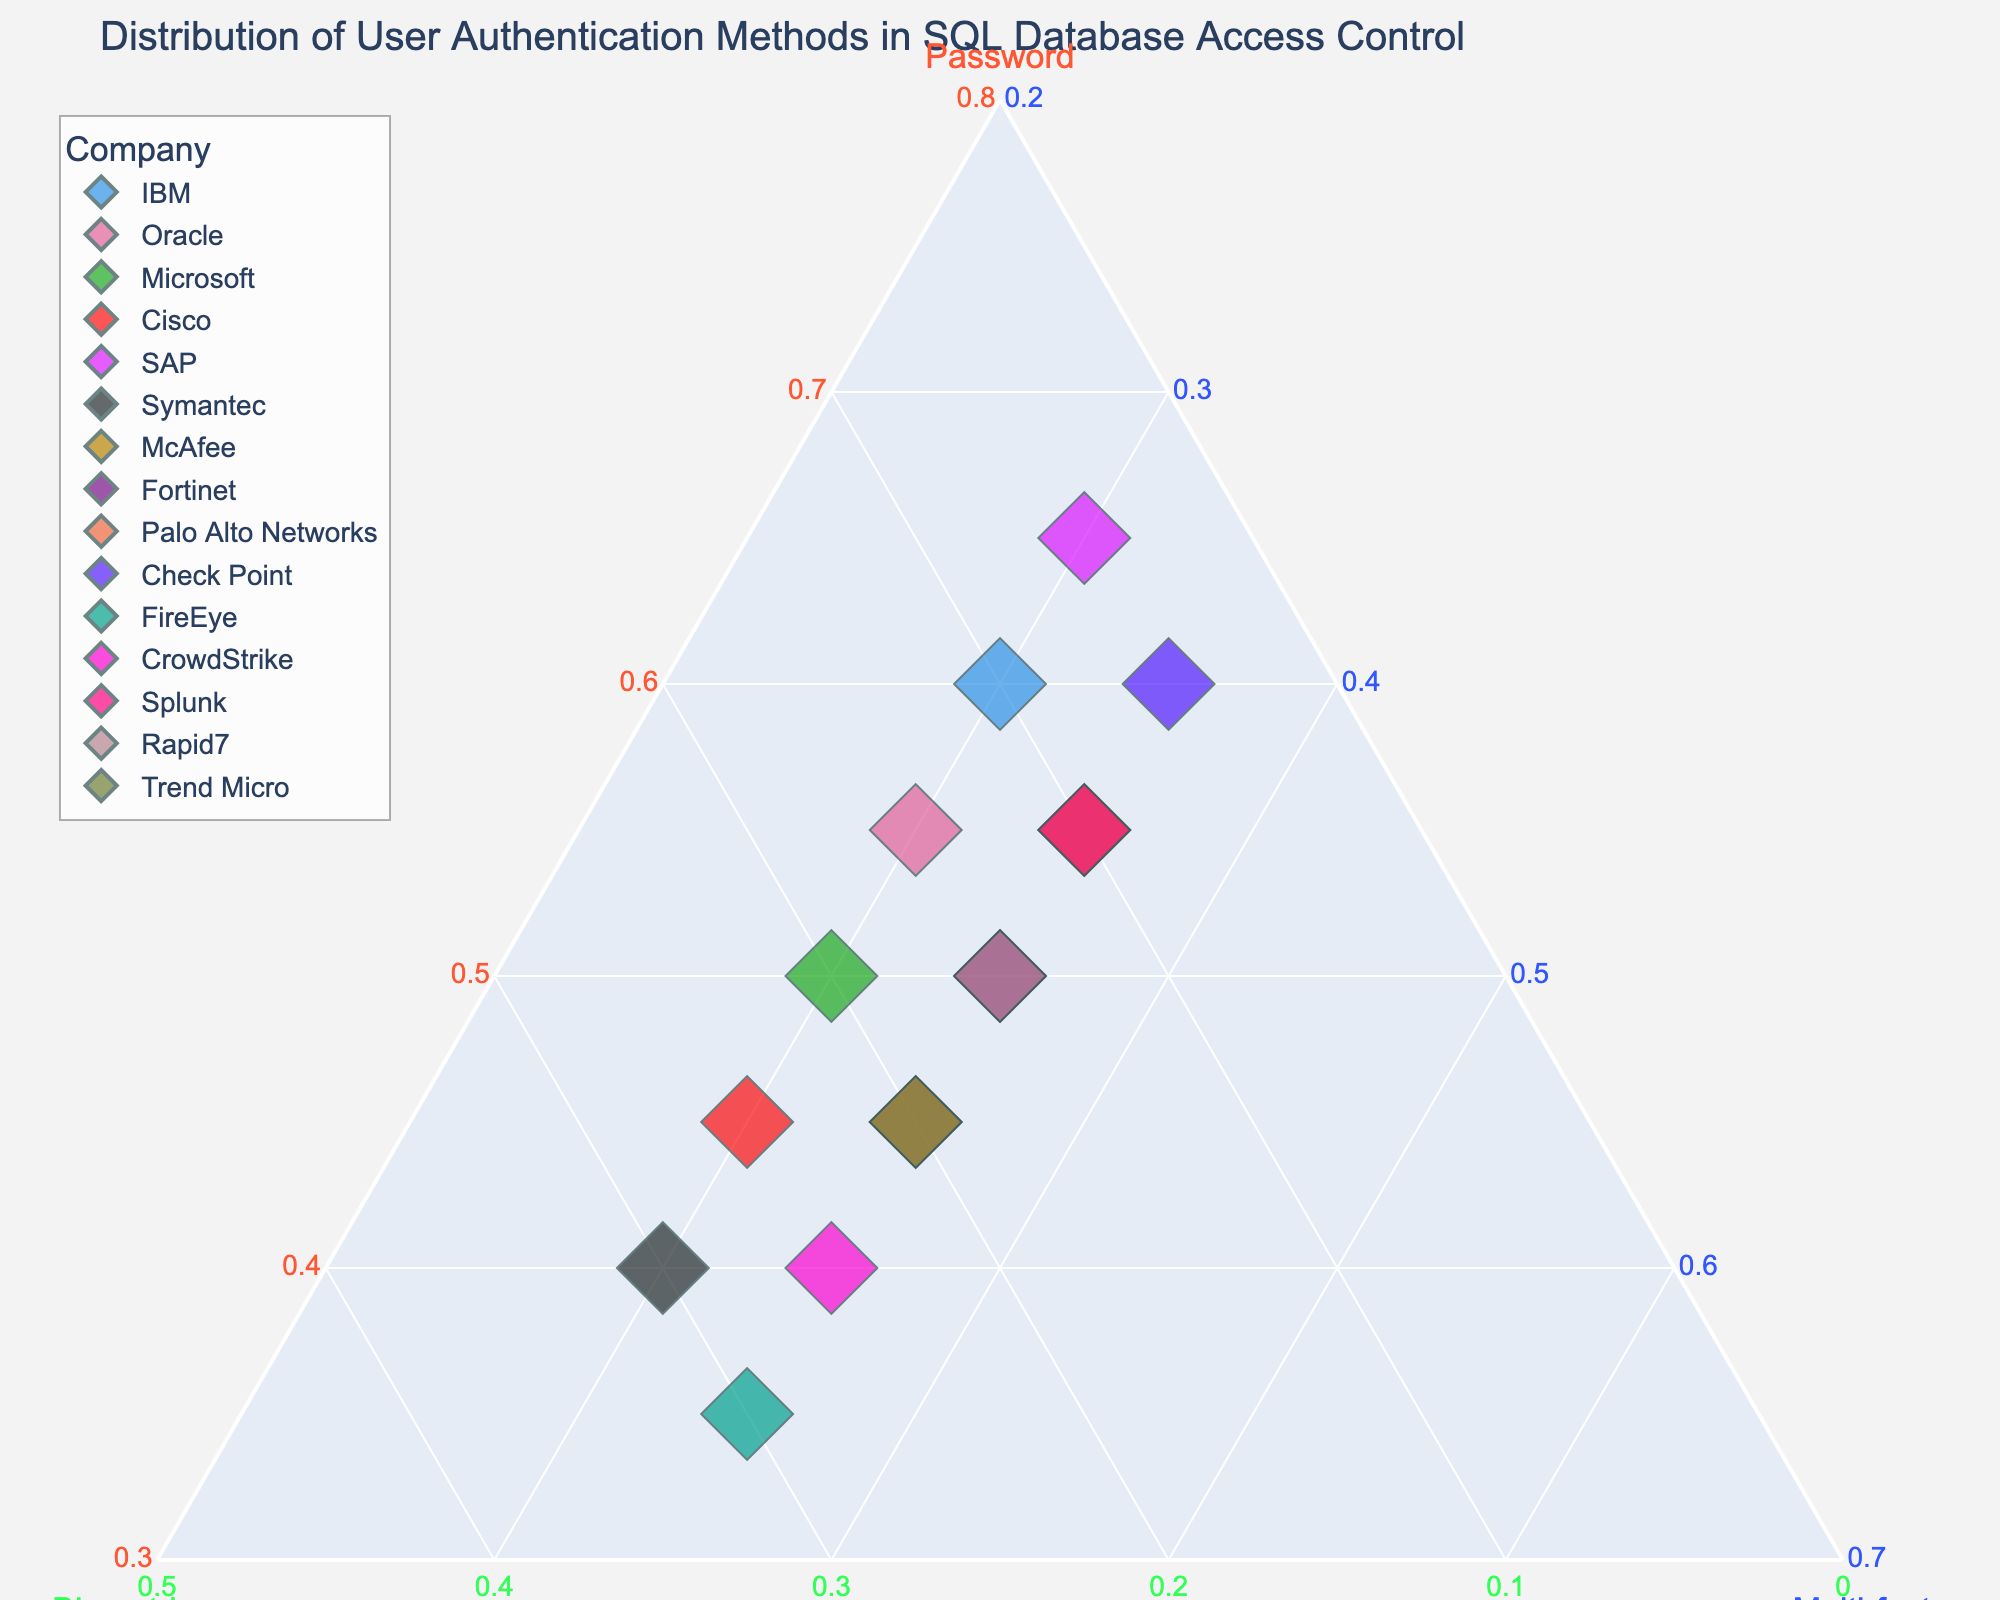What's the title of the figure? The title is prominently displayed at the top of the plot and provides a summary of what the plot represents.
Answer: Distribution of User Authentication Methods in SQL Database Access Control Which company has the highest value for biometric authentication? By looking at the plot, the company with the highest data point along the Biometric axis has the highest biometric authentication value.
Answer: Symantec Which company relies the least on multi-factor authentication? The company with the lowest data point along the Multi-factor axis represents the one that relies the least on multi-factor authentication.
Answer: SAP Between Microsoft and Cisco, which one has a higher percentage of password use? Look at the position of both companies along the Password axis. The one closer to the Password axis maximum value has the higher percentage.
Answer: Microsoft What is the total percentage of authentication methods for Trend Micro? By adding the normalized values for Password, Biometric, and Multi-factor (which should always sum up to 1), we confirm the distribution for Trend Micro.
Answer: 100% What pattern can be observed about the multi-factor authentication values across all companies? All companies are clustered along a vertical line in the plot where the Multi-factor axis stays constant, indicating a consistent value across all companies.
Answer: All have the same value Are there any companies with an equal distribution across all three authentication methods? For a company to have an equal distribution, it would need to be near the center of the ternary plot, where all three axes intersect at equal values.
Answer: No Which company shows greater reliance on biometric authentication compared to password authentication? Examine the position relative to the Biometric and Password axes. The company farther along the Biometric axis and nearer to the opposite of the Password axis fits this description.
Answer: FireEye How do Salesforce and Rapid7 compare in terms of their use of multi-factor authentication? Find the positions of Salesforce and Rapid7 along the Multi-factor axis and compare them directly.
Answer: Equal What is the general trend observed for the combination of password and biometric authentication among the companies? Observe the positions of companies along the Password and Biometric axes. A general trend can be identified based on the clustering of points.
Answer: Inverse relation (raising in Biometric, falling in Password) 